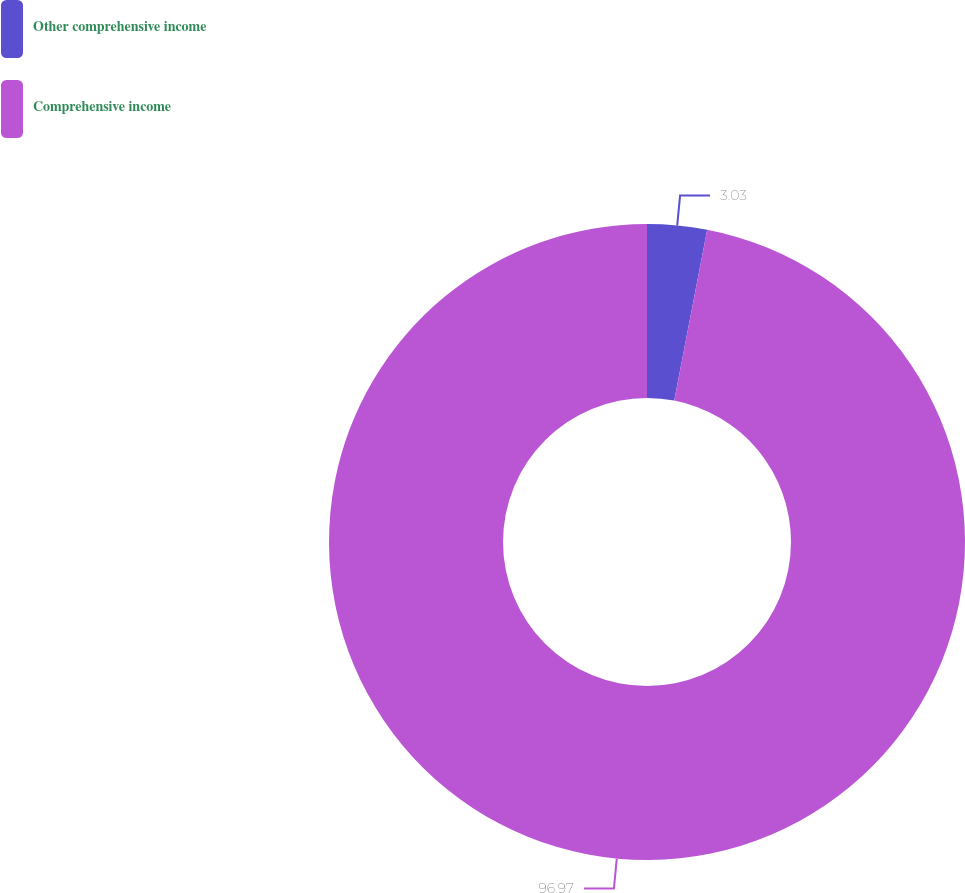<chart> <loc_0><loc_0><loc_500><loc_500><pie_chart><fcel>Other comprehensive income<fcel>Comprehensive income<nl><fcel>3.03%<fcel>96.97%<nl></chart> 